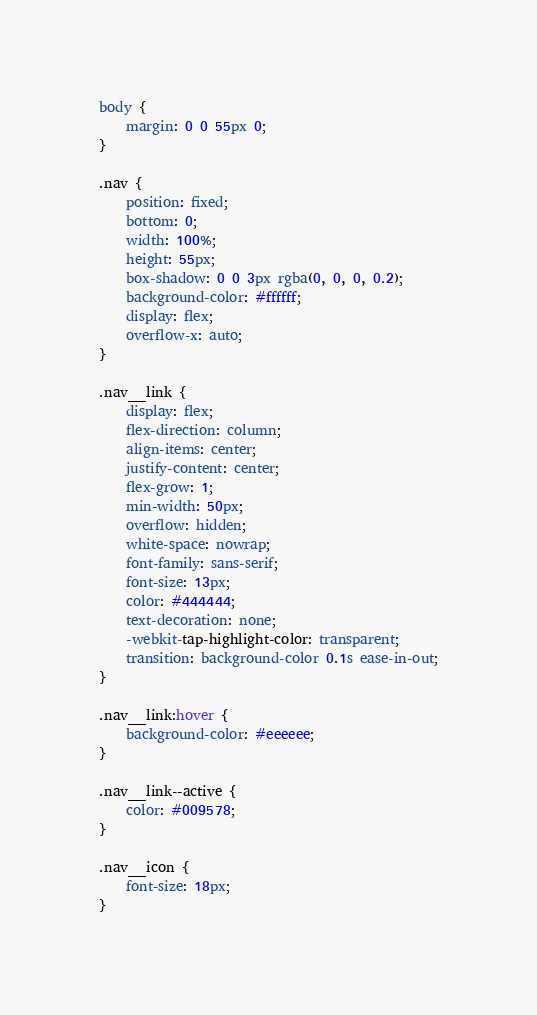<code> <loc_0><loc_0><loc_500><loc_500><_CSS_>body {
    margin: 0 0 55px 0;
}

.nav {
    position: fixed;
    bottom: 0;
    width: 100%;
    height: 55px;
    box-shadow: 0 0 3px rgba(0, 0, 0, 0.2);
    background-color: #ffffff;
    display: flex;
    overflow-x: auto;
}

.nav__link {
    display: flex;
    flex-direction: column;
    align-items: center;
    justify-content: center;
    flex-grow: 1;
    min-width: 50px;
    overflow: hidden;
    white-space: nowrap;
    font-family: sans-serif;
    font-size: 13px;
    color: #444444;
    text-decoration: none;
    -webkit-tap-highlight-color: transparent;
    transition: background-color 0.1s ease-in-out;
}

.nav__link:hover {
    background-color: #eeeeee;
}

.nav__link--active {
    color: #009578;
}

.nav__icon {
    font-size: 18px;
}

</code> 